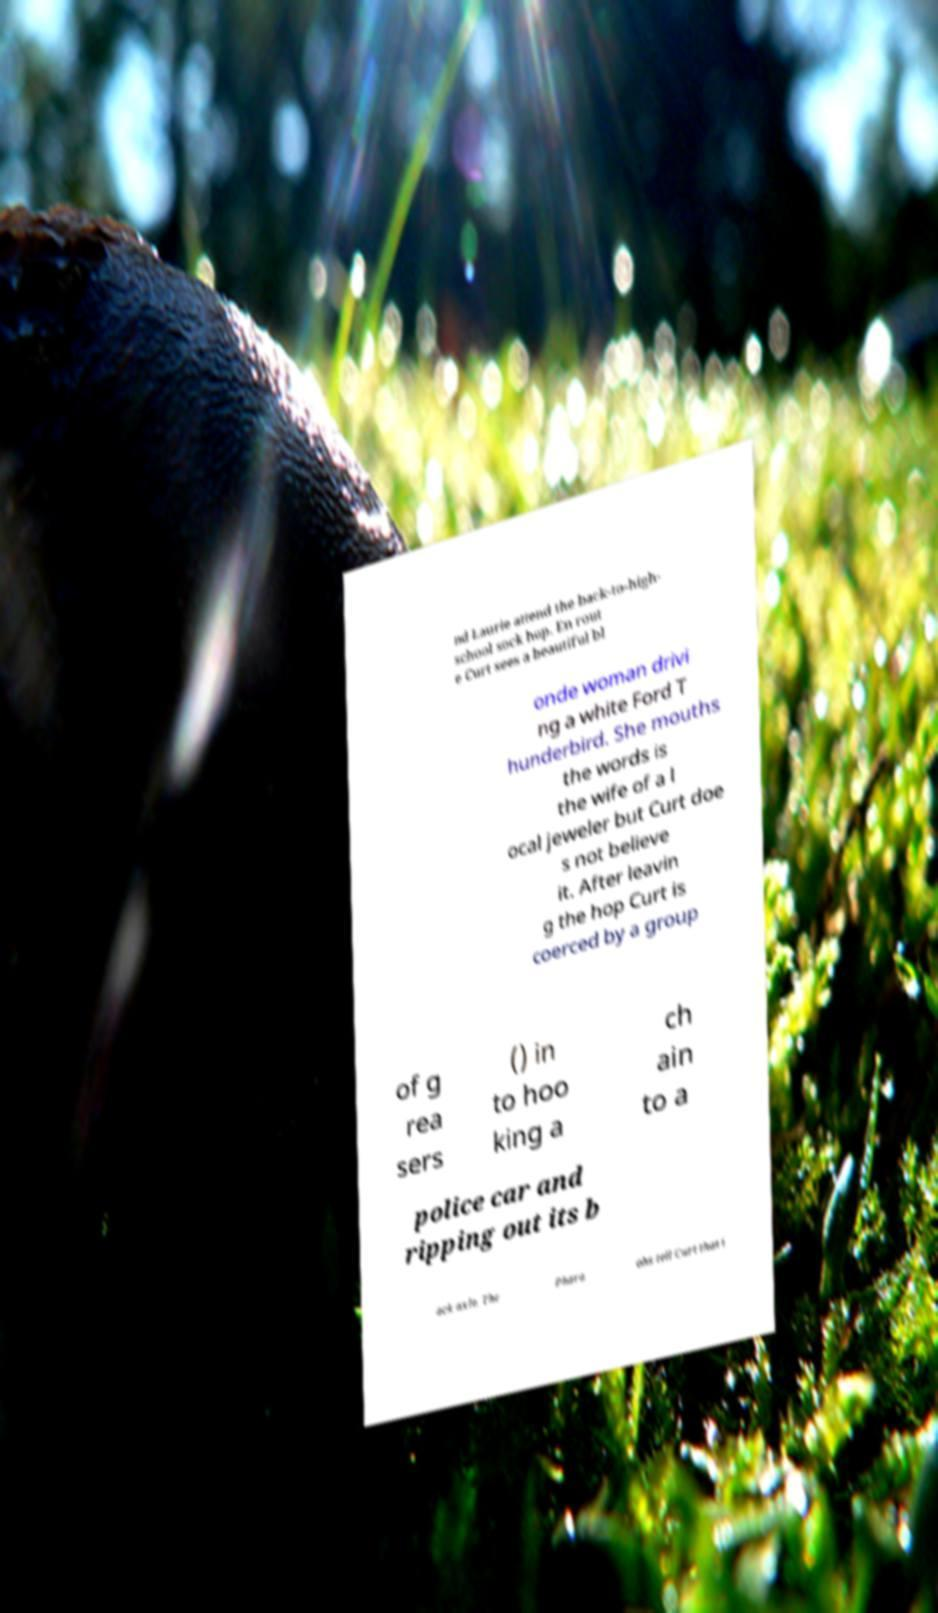For documentation purposes, I need the text within this image transcribed. Could you provide that? nd Laurie attend the back-to-high- school sock hop. En rout e Curt sees a beautiful bl onde woman drivi ng a white Ford T hunderbird. She mouths the words is the wife of a l ocal jeweler but Curt doe s not believe it. After leavin g the hop Curt is coerced by a group of g rea sers () in to hoo king a ch ain to a police car and ripping out its b ack axle. The Phara ohs tell Curt that i 